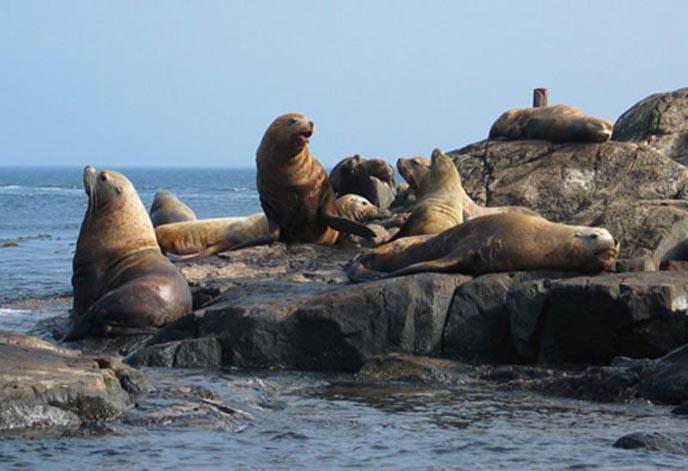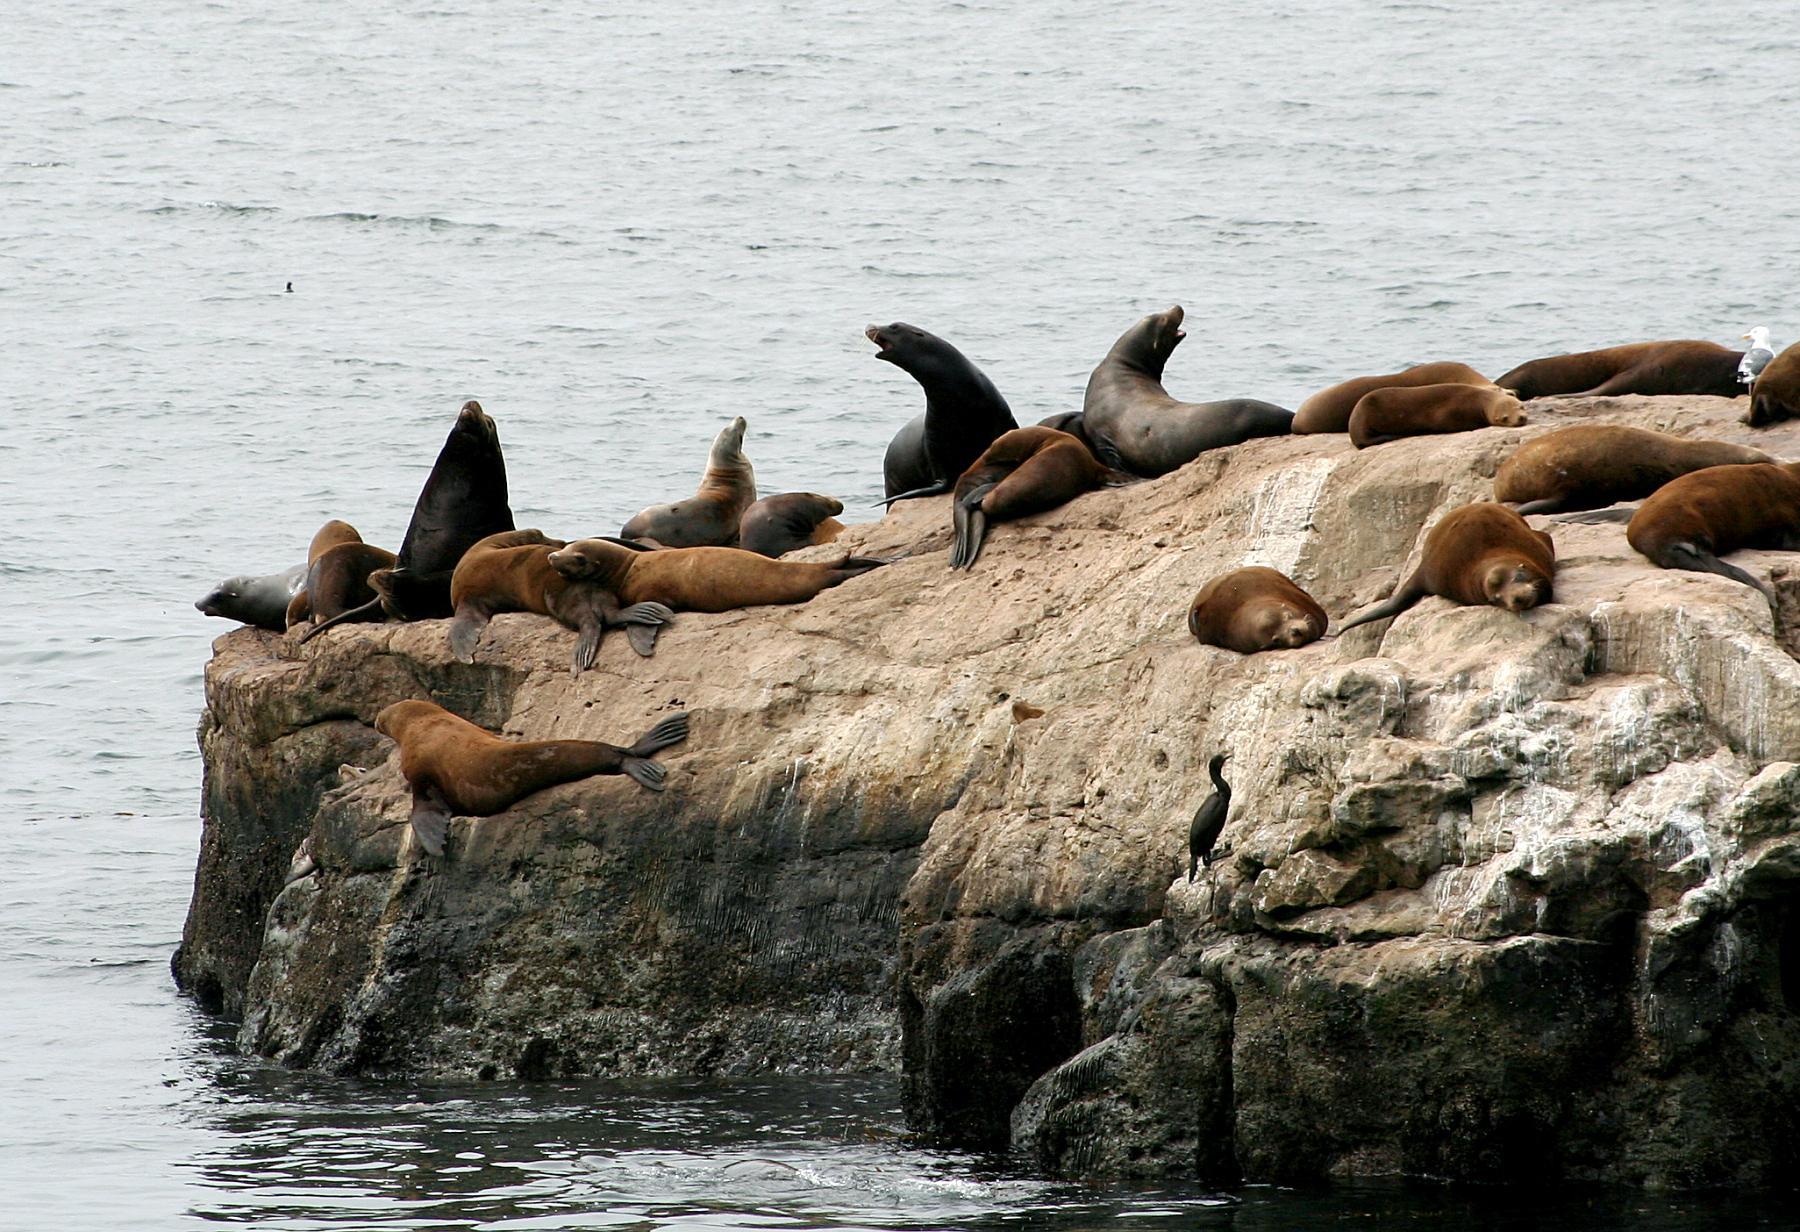The first image is the image on the left, the second image is the image on the right. Considering the images on both sides, is "An image shows a solitary sea lion facing left." valid? Answer yes or no. No. The first image is the image on the left, the second image is the image on the right. Evaluate the accuracy of this statement regarding the images: "There is one animal by the water in one of the images.". Is it true? Answer yes or no. No. 